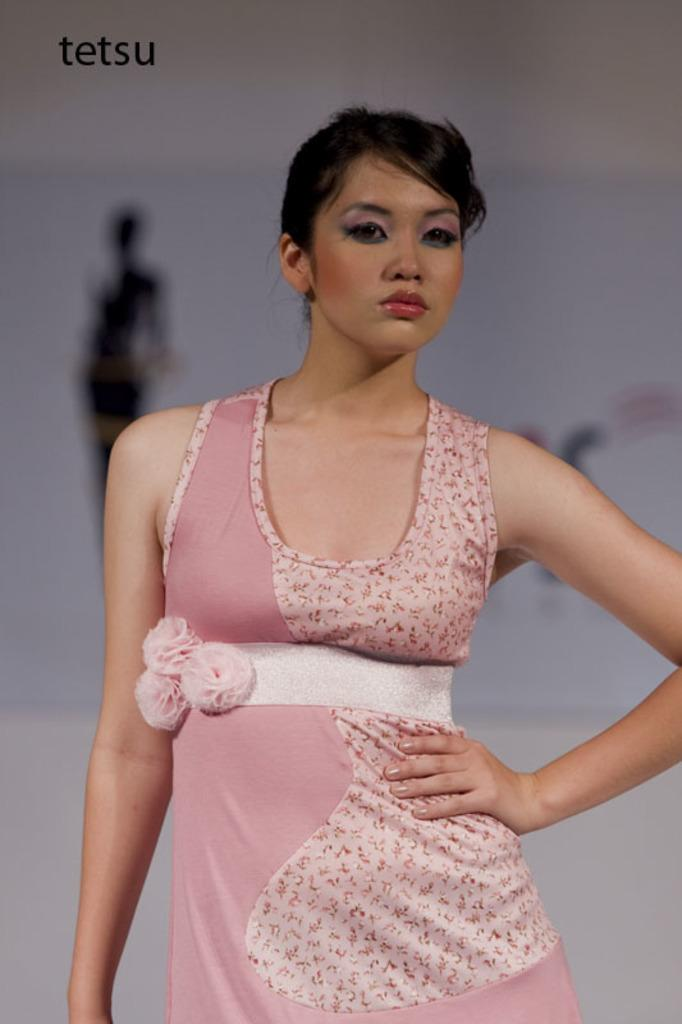Who is the main subject in the picture? There is a woman in the picture. What is the woman wearing? The woman is wearing a pink dress. Can you describe the background of the woman? The background of the woman is blurred. What type of vein can be seen on the woman's arm in the image? There is no visible vein on the woman's arm in the image. What is the woman holding in her hand in the image? The image does not show the woman holding anything in her hand. 